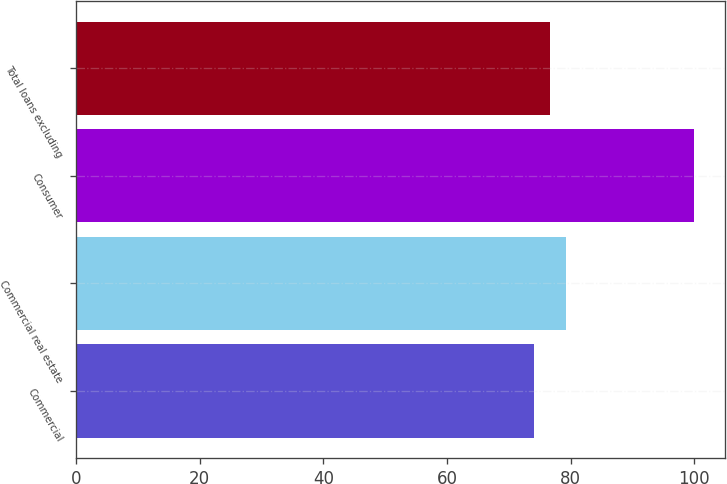Convert chart. <chart><loc_0><loc_0><loc_500><loc_500><bar_chart><fcel>Commercial<fcel>Commercial real estate<fcel>Consumer<fcel>Total loans excluding<nl><fcel>74<fcel>79.2<fcel>100<fcel>76.6<nl></chart> 